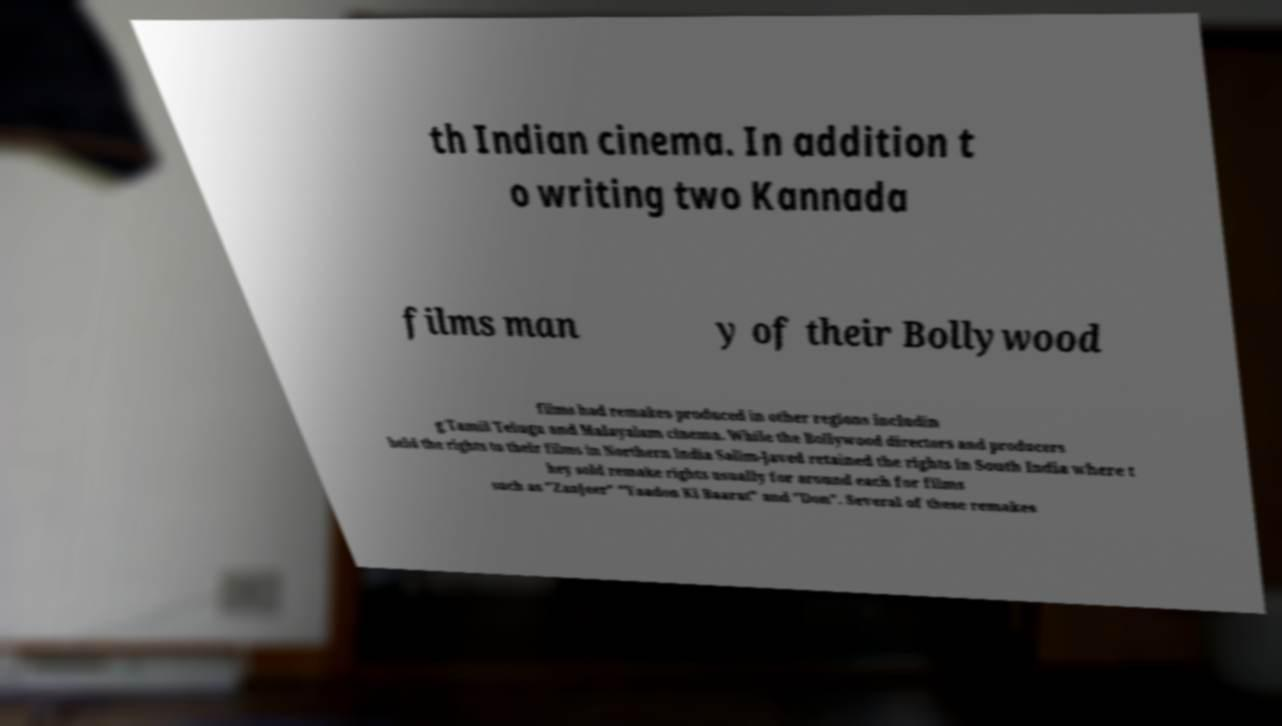Can you read and provide the text displayed in the image?This photo seems to have some interesting text. Can you extract and type it out for me? th Indian cinema. In addition t o writing two Kannada films man y of their Bollywood films had remakes produced in other regions includin g Tamil Telugu and Malayalam cinema. While the Bollywood directors and producers held the rights to their films in Northern India Salim-Javed retained the rights in South India where t hey sold remake rights usually for around each for films such as "Zanjeer" "Yaadon Ki Baarat" and "Don". Several of these remakes 